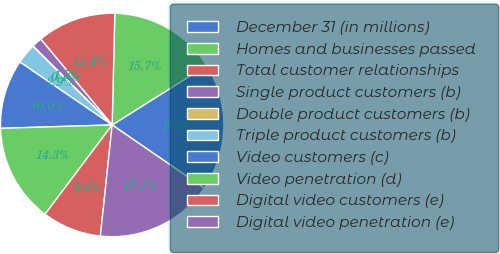Convert chart to OTSL. <chart><loc_0><loc_0><loc_500><loc_500><pie_chart><fcel>December 31 (in millions)<fcel>Homes and businesses passed<fcel>Total customer relationships<fcel>Single product customers (b)<fcel>Double product customers (b)<fcel>Triple product customers (b)<fcel>Video customers (c)<fcel>Video penetration (d)<fcel>Digital video customers (e)<fcel>Digital video penetration (e)<nl><fcel>18.52%<fcel>15.68%<fcel>11.42%<fcel>1.48%<fcel>0.06%<fcel>2.9%<fcel>10.0%<fcel>14.26%<fcel>8.58%<fcel>17.1%<nl></chart> 